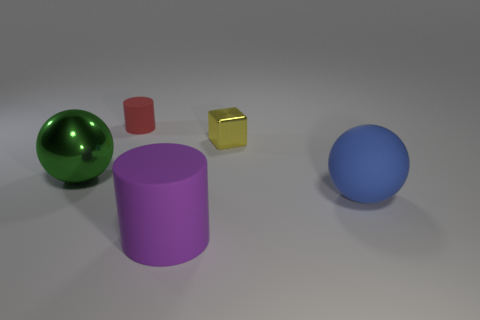What is the size of the sphere that is left of the large object that is right of the purple matte cylinder?
Ensure brevity in your answer.  Large. Does the large metal thing have the same color as the cylinder that is in front of the yellow metal object?
Offer a very short reply. No. What number of other objects are the same material as the large green object?
Provide a succinct answer. 1. There is a big blue thing that is made of the same material as the red cylinder; what shape is it?
Offer a terse response. Sphere. Is there any other thing that is the same color as the shiny sphere?
Give a very brief answer. No. Are there more big blue matte spheres in front of the large purple cylinder than gray metal cylinders?
Your response must be concise. No. There is a yellow metal object; is its shape the same as the matte thing in front of the large blue thing?
Ensure brevity in your answer.  No. What number of green metal objects have the same size as the yellow shiny cube?
Give a very brief answer. 0. How many large matte objects are behind the cylinder right of the tiny matte object to the left of the blue rubber thing?
Ensure brevity in your answer.  1. Are there the same number of green things that are in front of the large cylinder and tiny red rubber cylinders to the right of the tiny red thing?
Provide a short and direct response. Yes. 